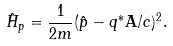<formula> <loc_0><loc_0><loc_500><loc_500>\hat { H } _ { p } = \frac { 1 } { 2 m } ( \hat { p } - q ^ { * } \mathbf A / c ) ^ { 2 } .</formula> 